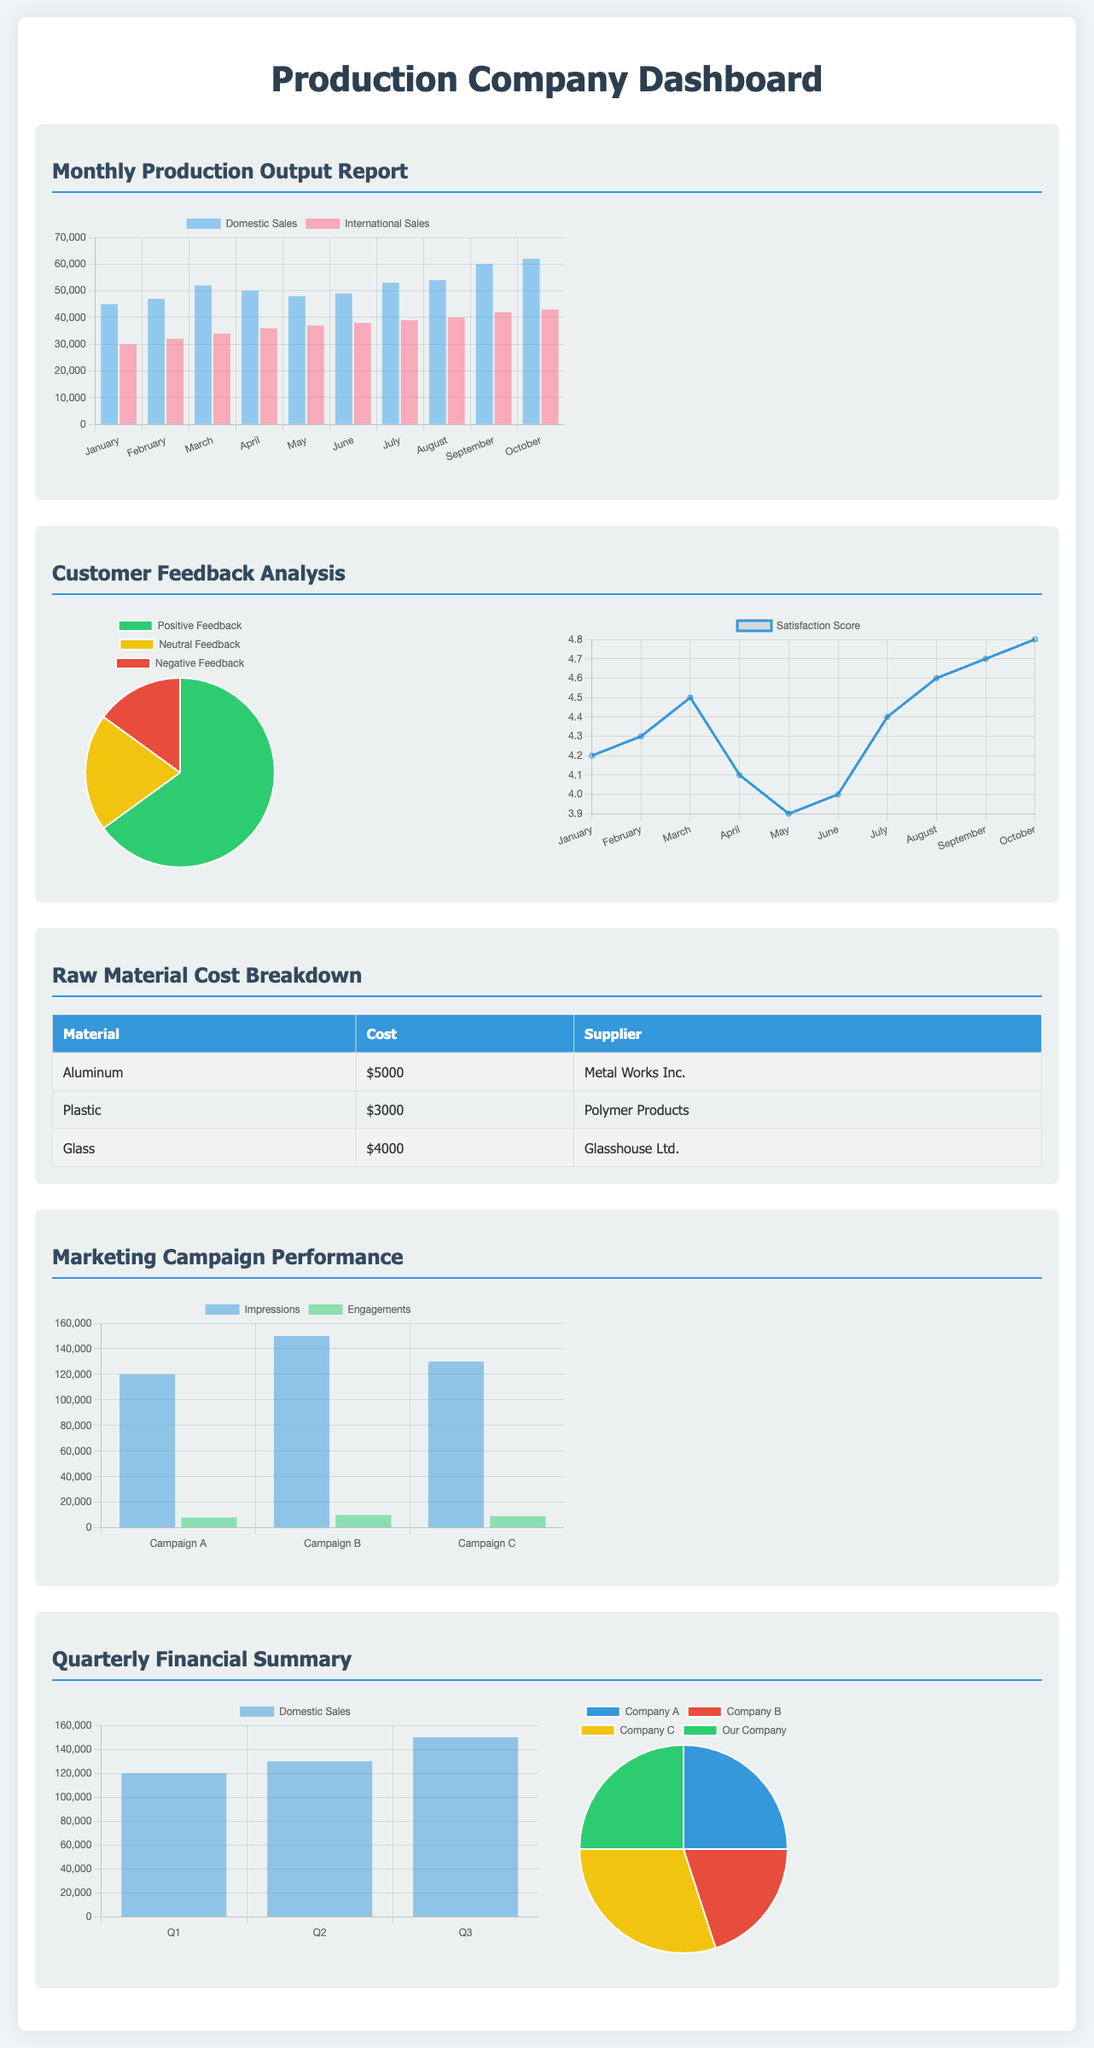what is the domestic sales figure for October? The document contains a bar chart showing the monthly production output report, and for October, the domestic sales figure is indicated.
Answer: 62000 what was the satisfaction score in July? The document provides a line chart for satisfaction scores by month, and July's score is displayed.
Answer: 4.4 how much does aluminum cost? The cost breakdown table in the document provides the pricing for various raw materials, including aluminum.
Answer: $5000 which supplier provides plastic? The raw material cost breakdown includes the names of suppliers for each material, specifying the supplier for plastic.
Answer: Polymer Products what is the total number of engagements for Campaign B? The campaign performance bar chart provides separate metrics for different campaigns, and for Campaign B the engagements number is indicated.
Answer: 10000 what is the market share percentage of Our Company? The market share pie chart provides the percentage breakdown between different companies, including Our Company.
Answer: 25 how many positive feedback responses were received? The feedback pie chart breaks down different feedback types, showing the percentage of positive feedback.
Answer: 65 which material has the highest cost? The raw material cost breakdown table lists all materials and their costs, indicating which material has the highest cost.
Answer: Glass what was the domestic sales figure in Q2? The sales growth chart provides data for domestic sales across different quarters, and for Q2 the figure is displayed.
Answer: 130000 